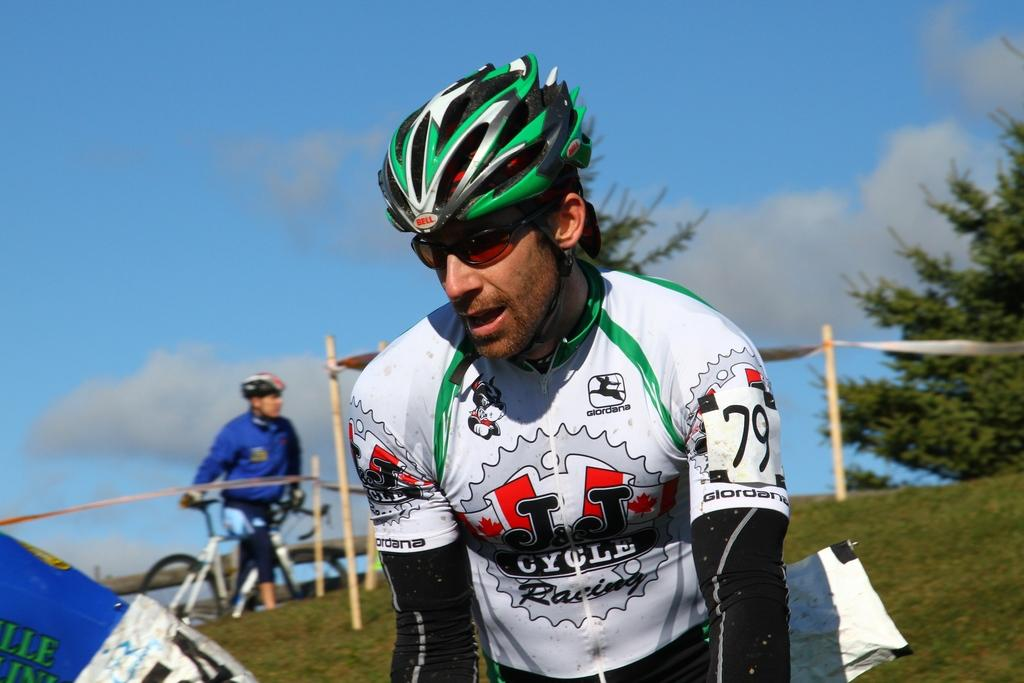What is the main subject of the picture? The main subject of the picture is a man. What is the man wearing on his face? The man is wearing spectacles. What is the man wearing on his head? The man is wearing a helmet on his head. What can be seen in the background of the picture? There are trees and clouds in the sky in the background of the picture. What type of thumb can be seen holding the helmet in the image? There is no thumb visible in the image, and the man is already wearing the helmet on his head. How many legs does the man have in the image? The man has two legs in the image, but this question is irrelevant as it does not pertain to any of the provided facts. 